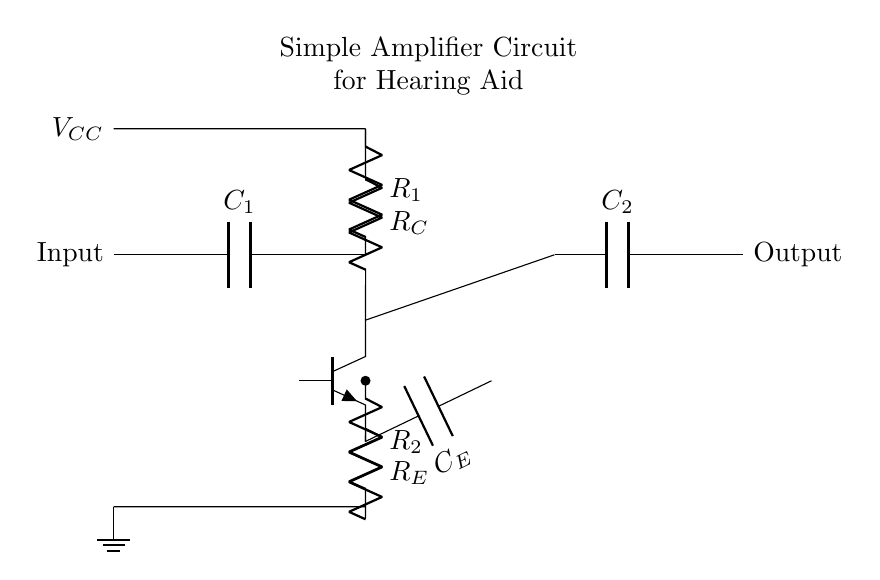What type of transistor is used in the circuit? The circuit uses an NPN transistor, which is indicated by the label on the transistor symbol in the diagram.
Answer: NPN What are the values of the capacitors in the circuit? The diagram shows two capacitors, labeled C1 and C2, but their numerical values are not specified in the circuit. Typically, these values would be defined elsewhere, but are not visible here.
Answer: Not specified What is the role of the resistor R_E in this circuit? Resistor R_E is the emitter resistor, which stabilizes the operating point of the transistor and helps control the gain and linearity of the amplifier.
Answer: Stabilizes operating point Which components are responsible for the input and output of the signal? The input is provided through the capacitor C1, and the output is taken through capacitor C2. Both capacitors couple AC signals while blocking DC voltage.
Answer: C1 and C2 How are resistors R_1 and R_2 connected to the transistor? R_1 is connected between the base and the voltage supply, establishing the base biasing, while R_2 connects the collector to ground, providing the necessary load for the amplifier.
Answer: R_1 to base; R_2 to collector What is the significance of the power supply voltage labeled \( V_{CC} \)? The power supply voltage \( V_{CC} \) is essential for providing the necessary bias and power to the transistor for its operation, determining the maximum output swing of the amplifier.
Answer: Provides bias and power 